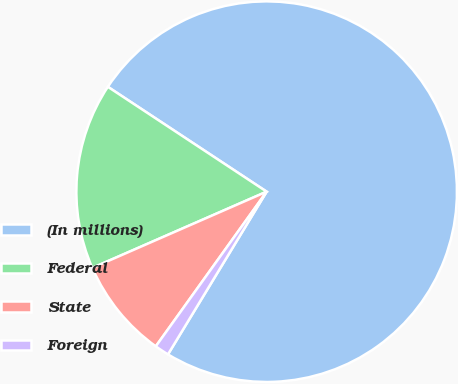Convert chart to OTSL. <chart><loc_0><loc_0><loc_500><loc_500><pie_chart><fcel>(In millions)<fcel>Federal<fcel>State<fcel>Foreign<nl><fcel>74.39%<fcel>15.85%<fcel>8.54%<fcel>1.22%<nl></chart> 